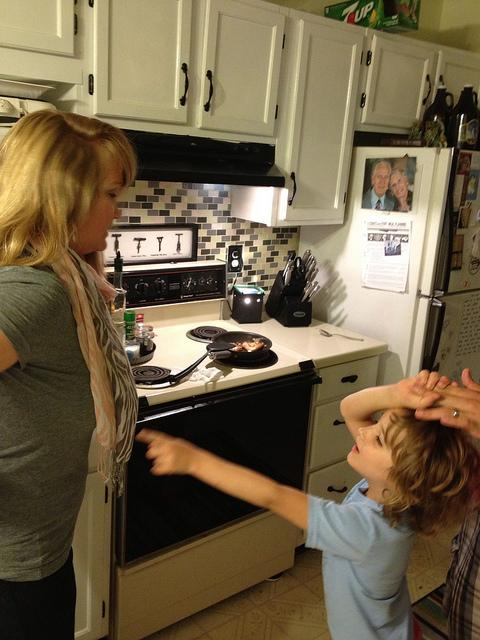What is the original flavor of the beverage?

Choices:
A) orange
B) grape
C) cherry
D) lemon-lime lemon-lime 